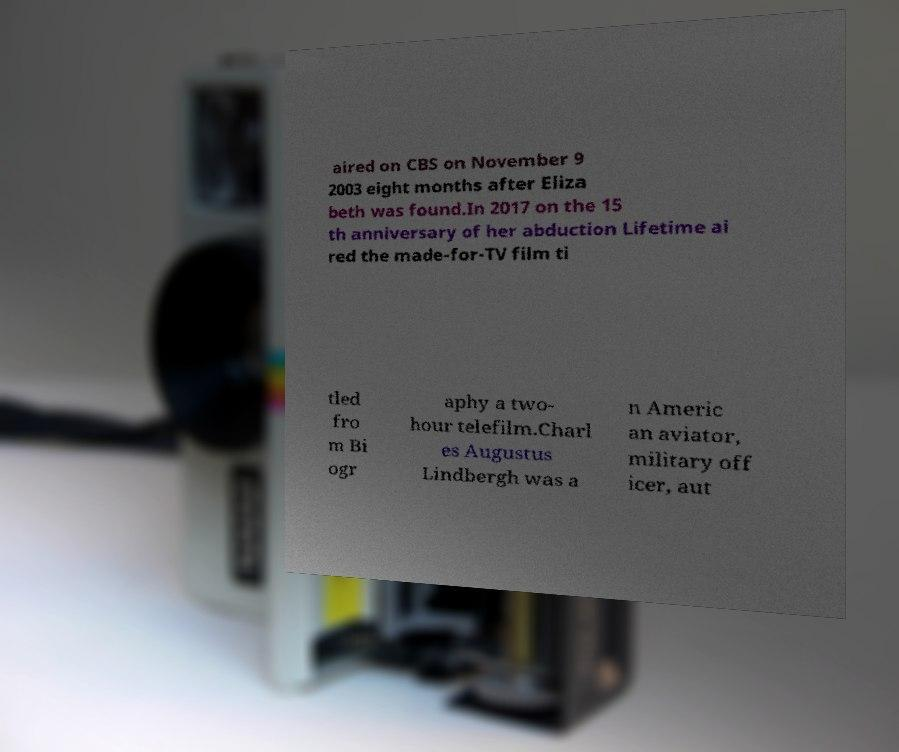Can you accurately transcribe the text from the provided image for me? aired on CBS on November 9 2003 eight months after Eliza beth was found.In 2017 on the 15 th anniversary of her abduction Lifetime ai red the made-for-TV film ti tled fro m Bi ogr aphy a two- hour telefilm.Charl es Augustus Lindbergh was a n Americ an aviator, military off icer, aut 